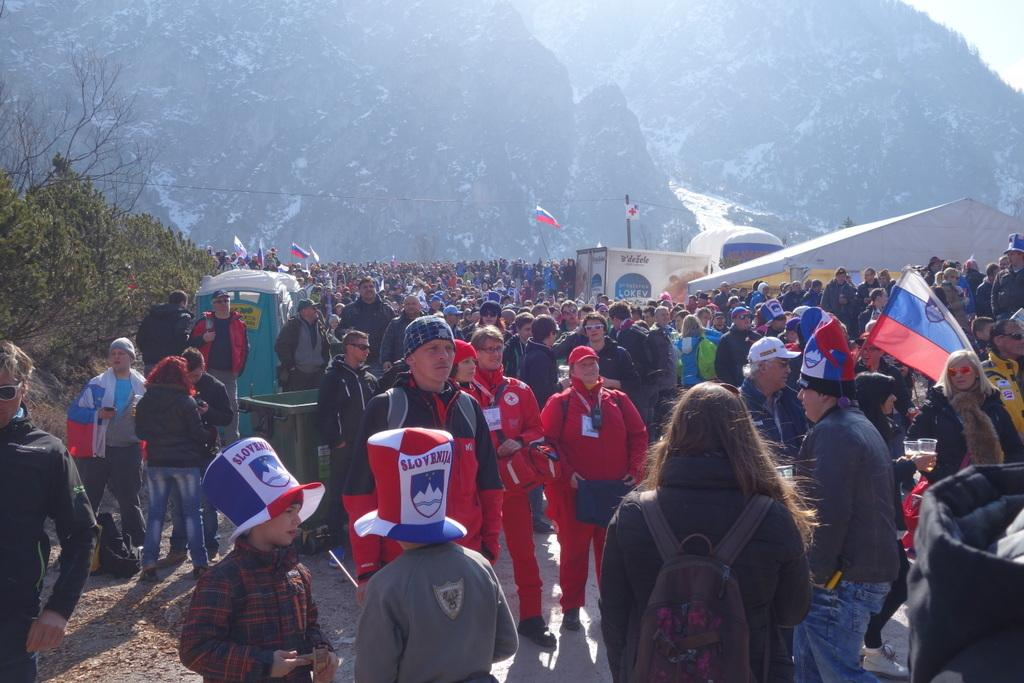What is the main focus of the image? The main focus of the image is the many people in the center. What can be seen on the left side of the image? There are plants on the left side of the image. What is visible in the background of the image? There are mountains in the background of the image. Can you see the root of the plants on the left side of the image? There is no mention of a root in the image, only the plants themselves are visible. Is the seashore visible in the background of the image? The image does not show a seashore; it features mountains in the background. 